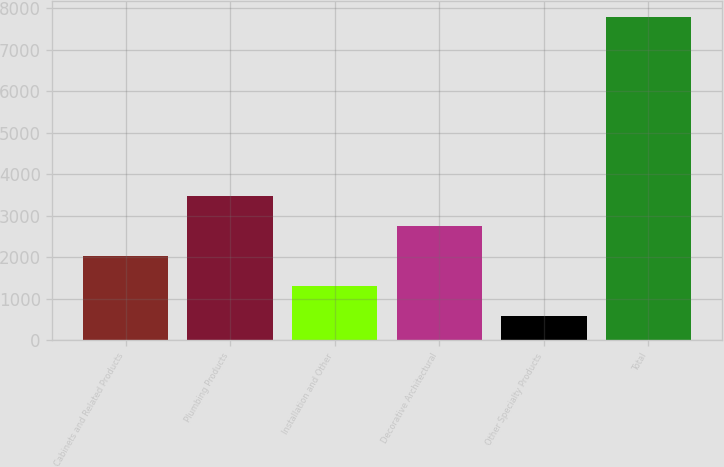<chart> <loc_0><loc_0><loc_500><loc_500><bar_chart><fcel>Cabinets and Related Products<fcel>Plumbing Products<fcel>Installation and Other<fcel>Decorative Architectural<fcel>Other Specialty Products<fcel>Total<nl><fcel>2025.6<fcel>3467.2<fcel>1304.8<fcel>2746.4<fcel>584<fcel>7792<nl></chart> 